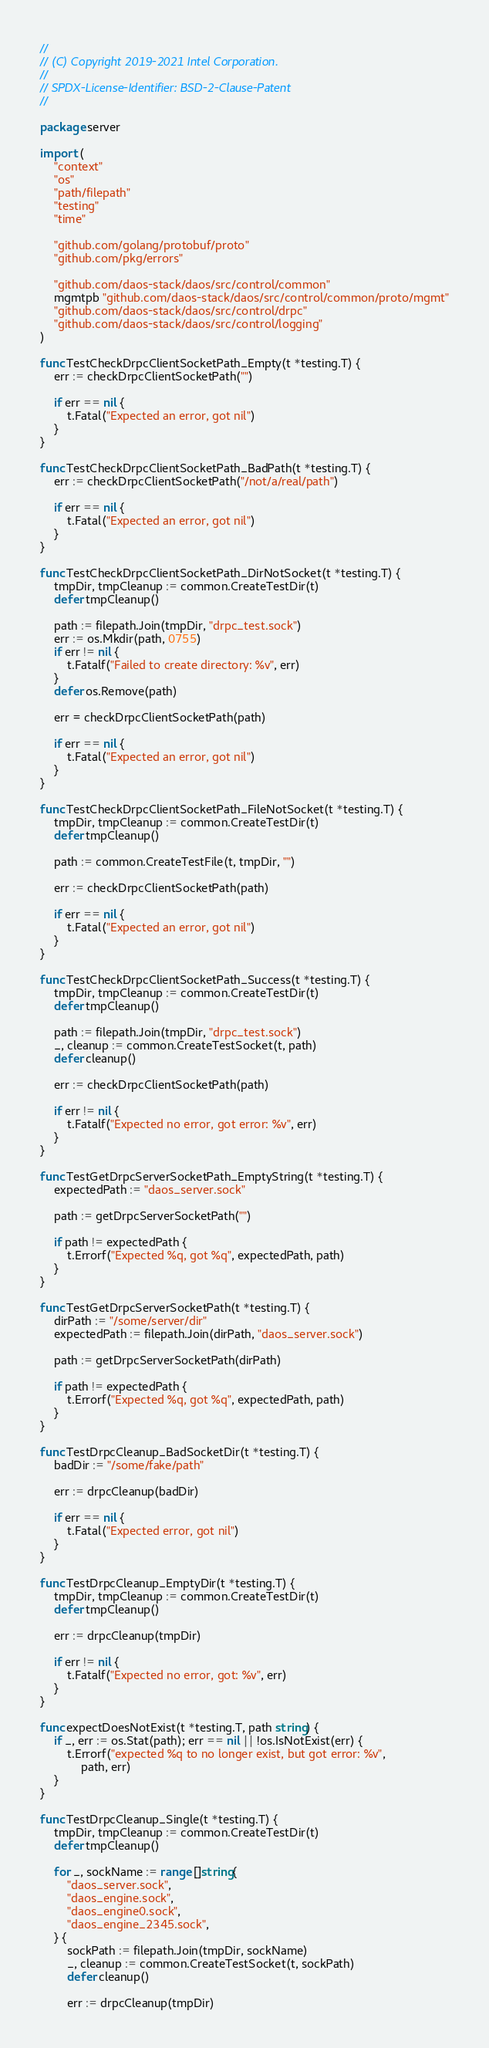Convert code to text. <code><loc_0><loc_0><loc_500><loc_500><_Go_>//
// (C) Copyright 2019-2021 Intel Corporation.
//
// SPDX-License-Identifier: BSD-2-Clause-Patent
//

package server

import (
	"context"
	"os"
	"path/filepath"
	"testing"
	"time"

	"github.com/golang/protobuf/proto"
	"github.com/pkg/errors"

	"github.com/daos-stack/daos/src/control/common"
	mgmtpb "github.com/daos-stack/daos/src/control/common/proto/mgmt"
	"github.com/daos-stack/daos/src/control/drpc"
	"github.com/daos-stack/daos/src/control/logging"
)

func TestCheckDrpcClientSocketPath_Empty(t *testing.T) {
	err := checkDrpcClientSocketPath("")

	if err == nil {
		t.Fatal("Expected an error, got nil")
	}
}

func TestCheckDrpcClientSocketPath_BadPath(t *testing.T) {
	err := checkDrpcClientSocketPath("/not/a/real/path")

	if err == nil {
		t.Fatal("Expected an error, got nil")
	}
}

func TestCheckDrpcClientSocketPath_DirNotSocket(t *testing.T) {
	tmpDir, tmpCleanup := common.CreateTestDir(t)
	defer tmpCleanup()

	path := filepath.Join(tmpDir, "drpc_test.sock")
	err := os.Mkdir(path, 0755)
	if err != nil {
		t.Fatalf("Failed to create directory: %v", err)
	}
	defer os.Remove(path)

	err = checkDrpcClientSocketPath(path)

	if err == nil {
		t.Fatal("Expected an error, got nil")
	}
}

func TestCheckDrpcClientSocketPath_FileNotSocket(t *testing.T) {
	tmpDir, tmpCleanup := common.CreateTestDir(t)
	defer tmpCleanup()

	path := common.CreateTestFile(t, tmpDir, "")

	err := checkDrpcClientSocketPath(path)

	if err == nil {
		t.Fatal("Expected an error, got nil")
	}
}

func TestCheckDrpcClientSocketPath_Success(t *testing.T) {
	tmpDir, tmpCleanup := common.CreateTestDir(t)
	defer tmpCleanup()

	path := filepath.Join(tmpDir, "drpc_test.sock")
	_, cleanup := common.CreateTestSocket(t, path)
	defer cleanup()

	err := checkDrpcClientSocketPath(path)

	if err != nil {
		t.Fatalf("Expected no error, got error: %v", err)
	}
}

func TestGetDrpcServerSocketPath_EmptyString(t *testing.T) {
	expectedPath := "daos_server.sock"

	path := getDrpcServerSocketPath("")

	if path != expectedPath {
		t.Errorf("Expected %q, got %q", expectedPath, path)
	}
}

func TestGetDrpcServerSocketPath(t *testing.T) {
	dirPath := "/some/server/dir"
	expectedPath := filepath.Join(dirPath, "daos_server.sock")

	path := getDrpcServerSocketPath(dirPath)

	if path != expectedPath {
		t.Errorf("Expected %q, got %q", expectedPath, path)
	}
}

func TestDrpcCleanup_BadSocketDir(t *testing.T) {
	badDir := "/some/fake/path"

	err := drpcCleanup(badDir)

	if err == nil {
		t.Fatal("Expected error, got nil")
	}
}

func TestDrpcCleanup_EmptyDir(t *testing.T) {
	tmpDir, tmpCleanup := common.CreateTestDir(t)
	defer tmpCleanup()

	err := drpcCleanup(tmpDir)

	if err != nil {
		t.Fatalf("Expected no error, got: %v", err)
	}
}

func expectDoesNotExist(t *testing.T, path string) {
	if _, err := os.Stat(path); err == nil || !os.IsNotExist(err) {
		t.Errorf("expected %q to no longer exist, but got error: %v",
			path, err)
	}
}

func TestDrpcCleanup_Single(t *testing.T) {
	tmpDir, tmpCleanup := common.CreateTestDir(t)
	defer tmpCleanup()

	for _, sockName := range []string{
		"daos_server.sock",
		"daos_engine.sock",
		"daos_engine0.sock",
		"daos_engine_2345.sock",
	} {
		sockPath := filepath.Join(tmpDir, sockName)
		_, cleanup := common.CreateTestSocket(t, sockPath)
		defer cleanup()

		err := drpcCleanup(tmpDir)
</code> 